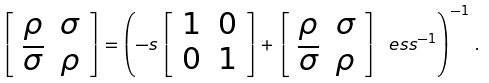<formula> <loc_0><loc_0><loc_500><loc_500>\left [ \begin{array} { c c } \rho & \sigma \\ \overline { \sigma } & \rho \end{array} \right ] = \left ( - s \left [ \begin{array} { c c } 1 & 0 \\ 0 & 1 \end{array} \right ] + \left [ \begin{array} { c c } \rho & \sigma \\ \overline { \sigma } & \rho \end{array} \right ] _ { \ } e s s ^ { - 1 } \right ) ^ { - 1 } \, .</formula> 